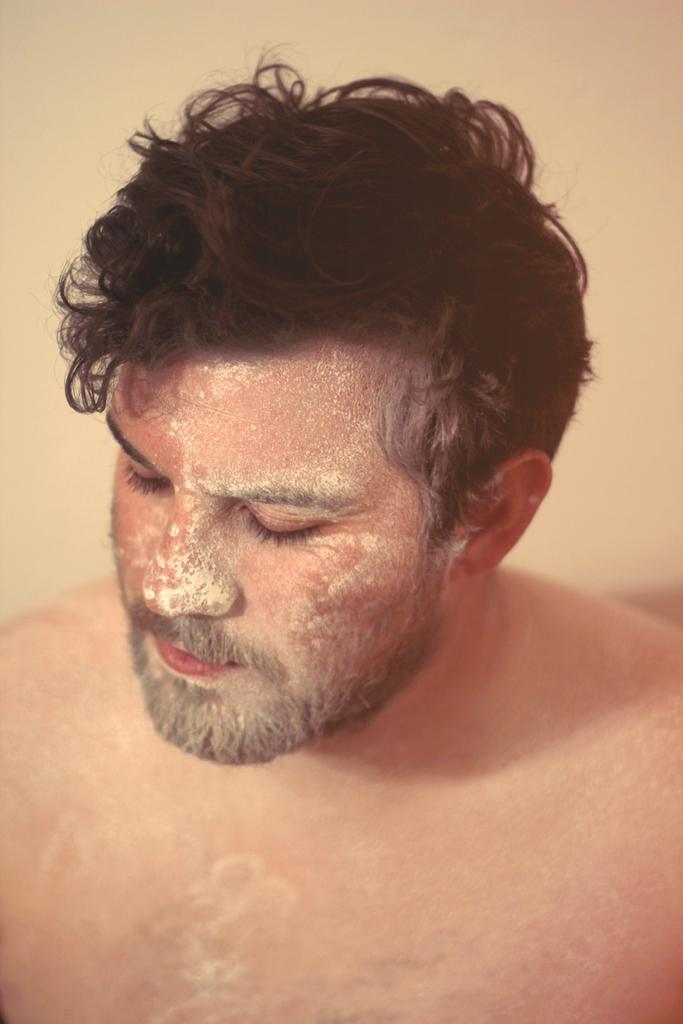What is the main subject of the image? There is a man in the image. What country is the man from in the image? There is no information provided about the man's country of origin, so it cannot be determined from the image. What type of noise is the man making in the image? There is no information provided about any noise or sounds in the image, so it cannot be determined. 